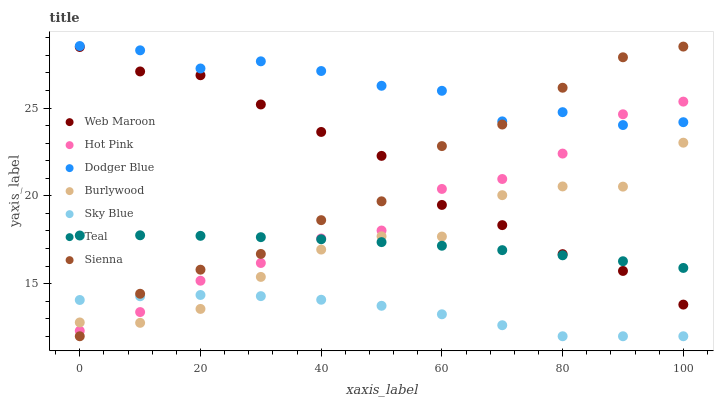Does Sky Blue have the minimum area under the curve?
Answer yes or no. Yes. Does Dodger Blue have the maximum area under the curve?
Answer yes or no. Yes. Does Hot Pink have the minimum area under the curve?
Answer yes or no. No. Does Hot Pink have the maximum area under the curve?
Answer yes or no. No. Is Teal the smoothest?
Answer yes or no. Yes. Is Burlywood the roughest?
Answer yes or no. Yes. Is Hot Pink the smoothest?
Answer yes or no. No. Is Hot Pink the roughest?
Answer yes or no. No. Does Sienna have the lowest value?
Answer yes or no. Yes. Does Hot Pink have the lowest value?
Answer yes or no. No. Does Dodger Blue have the highest value?
Answer yes or no. Yes. Does Hot Pink have the highest value?
Answer yes or no. No. Is Web Maroon less than Dodger Blue?
Answer yes or no. Yes. Is Dodger Blue greater than Sky Blue?
Answer yes or no. Yes. Does Hot Pink intersect Burlywood?
Answer yes or no. Yes. Is Hot Pink less than Burlywood?
Answer yes or no. No. Is Hot Pink greater than Burlywood?
Answer yes or no. No. Does Web Maroon intersect Dodger Blue?
Answer yes or no. No. 